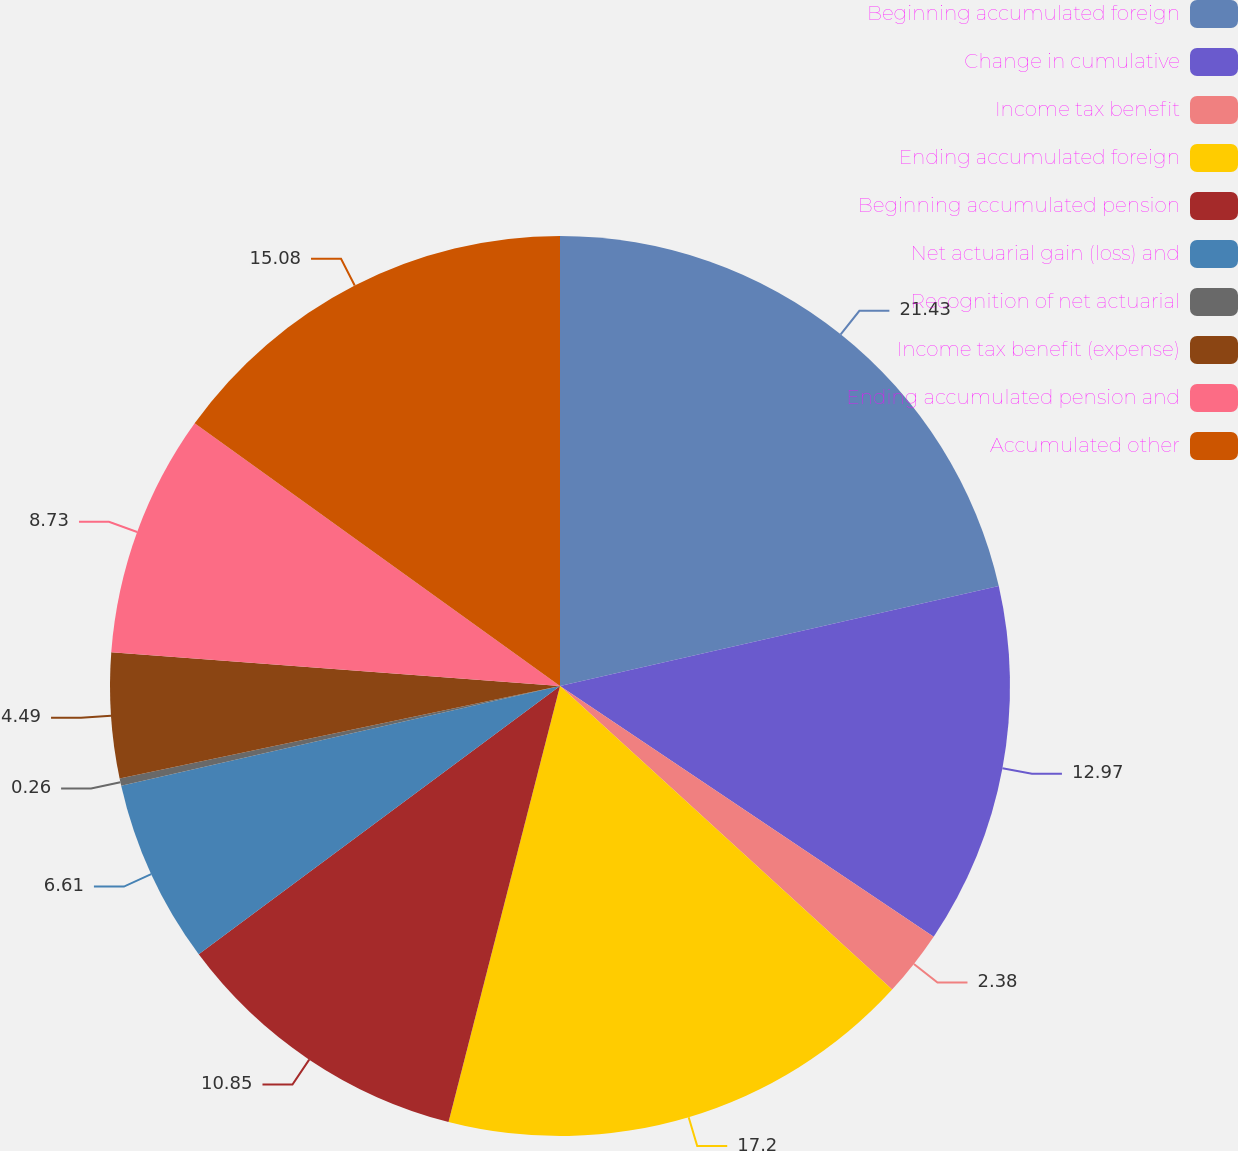Convert chart. <chart><loc_0><loc_0><loc_500><loc_500><pie_chart><fcel>Beginning accumulated foreign<fcel>Change in cumulative<fcel>Income tax benefit<fcel>Ending accumulated foreign<fcel>Beginning accumulated pension<fcel>Net actuarial gain (loss) and<fcel>Recognition of net actuarial<fcel>Income tax benefit (expense)<fcel>Ending accumulated pension and<fcel>Accumulated other<nl><fcel>21.44%<fcel>12.97%<fcel>2.38%<fcel>17.2%<fcel>10.85%<fcel>6.61%<fcel>0.26%<fcel>4.49%<fcel>8.73%<fcel>15.08%<nl></chart> 